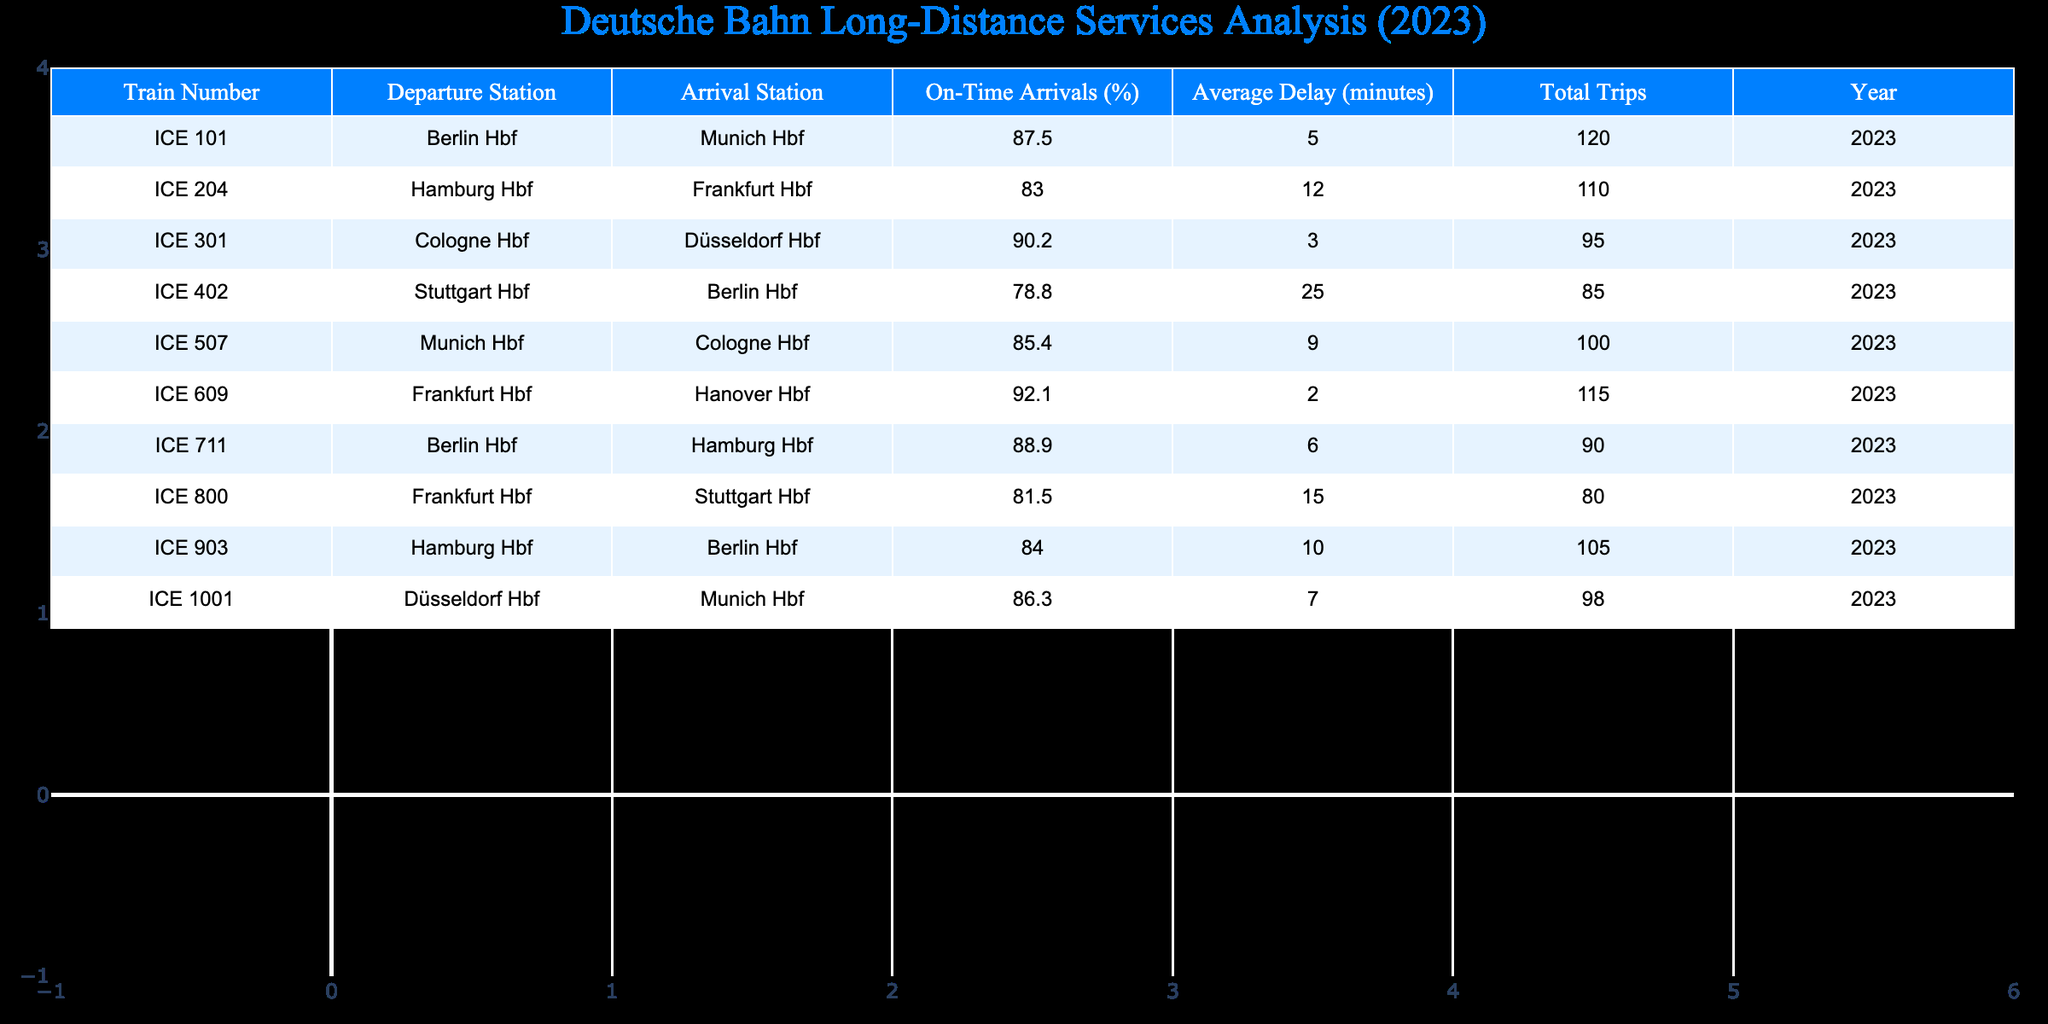What is the highest percentage of on-time arrivals among the trains listed? Looking at the "On-Time Arrivals (%)" column, the highest value is 92.1, which corresponds to the train ICE 609 (Frankfurt Hbf to Hanover Hbf).
Answer: 92.1 Which train has the longest average delay? By examining the "Average Delay (minutes)" column, the highest delay is 25 minutes, which is associated with train ICE 402 (Stuttgart Hbf to Berlin Hbf).
Answer: 25 How many trains reported an on-time arrival percentage above 85%? Counting the rows where "On-Time Arrivals (%)" is greater than 85%, we find ICE 101, ICE 301, ICE 609, ICE 711, and ICE 1001. This totals to five trains.
Answer: 5 What is the average on-time arrival percentage of all the trains? To calculate the average, sum the on-time percentages: (87.5 + 83.0 + 90.2 + 78.8 + 85.4 + 92.1 + 88.9 + 81.5 + 84.0 + 86.3) = 866.2, then divide by the total number of trains (10): 866.2 / 10 = 86.62.
Answer: 86.62 Is the average delay of ICE 204 greater than the average delay of ICE 507? Compare average delays: ICE 204 has an average delay of 12 minutes, while ICE 507 has 9 minutes. Since 12 is greater than 9, the statement is true.
Answer: Yes Which train(s) arrive on-time and have an average delay of less than 5 minutes? Looking for "On-Time Arrivals (%)" at 100% and "Average Delay (minutes)" less than 5, we find no trains that meet these criteria.
Answer: No What is the total number of trips for trains that have an on-time arrival percentage below 85%? Sum the "Total Trips" for the trains with below 85% on-time arrival: ICE 204 (110) + ICE 402 (85) + ICE 800 (80) = 275.
Answer: 275 Which train shows the least delay and what is the percentage of on-time arrival for that train? The train with the least delay is ICE 609, which has an average delay of 2 minutes and an on-time arrival percentage of 92.1.
Answer: ICE 609, 92.1 How many trains went from Berlin Hbf to another station? The trains departing from Berlin Hbf are ICE 101 (to Munich Hbf), ICE 402 (to Stuttgart Hbf), and ICE 711 (to Hamburg Hbf). This totals three trains.
Answer: 3 